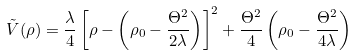<formula> <loc_0><loc_0><loc_500><loc_500>\tilde { V } ( \rho ) = \frac { \lambda } { 4 } \left [ \rho - \left ( \rho _ { 0 } - \frac { \Theta ^ { 2 } } { 2 \lambda } \right ) \right ] ^ { 2 } + \frac { \Theta ^ { 2 } } { 4 } \left ( \rho _ { 0 } - \frac { \Theta ^ { 2 } } { 4 \lambda } \right )</formula> 